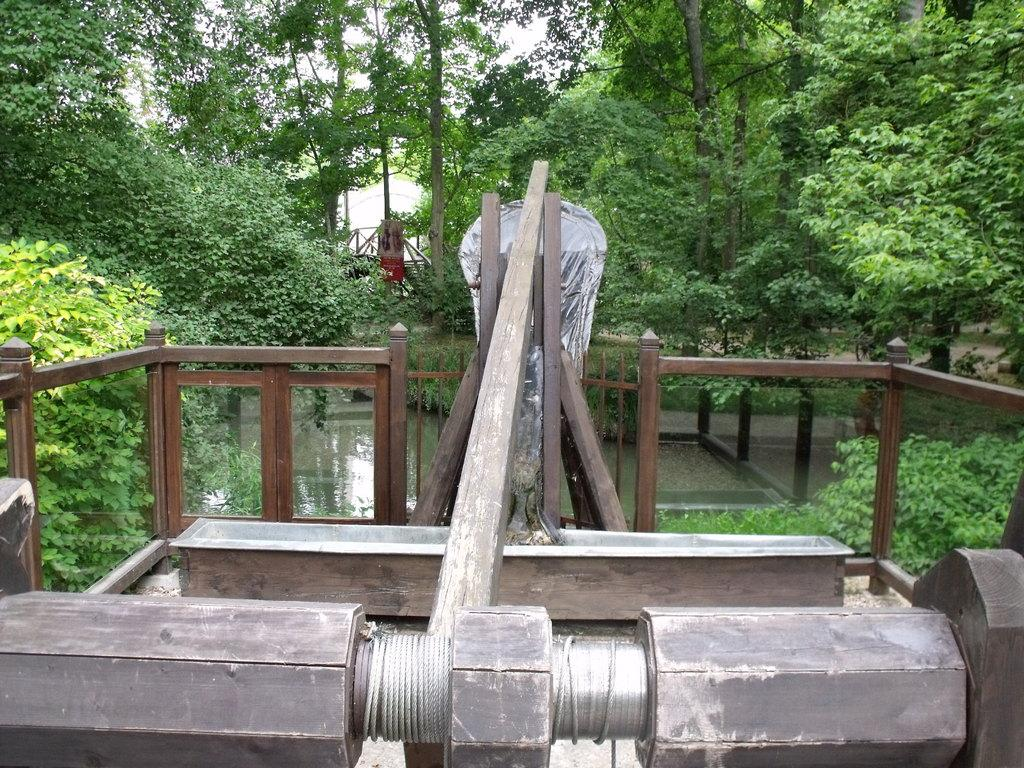What type of structure can be seen in the image? There is fencing in the image. What material are the poles made of in the image? The poles in the image are made of wood. What is the thin, string-like object in the image? There is a thread in the image. What type of vegetation is present in the image? There are plants and trees in the image. What part of the natural environment is visible in the image? The sky and water are visible in the image. What type of treatment is being administered to the cannon in the image? There is no cannon present in the image, so no treatment is being administered. What is the weight of the plants in the image? The weight of the plants cannot be determined from the image alone, as it does not provide any information about their size or density. 